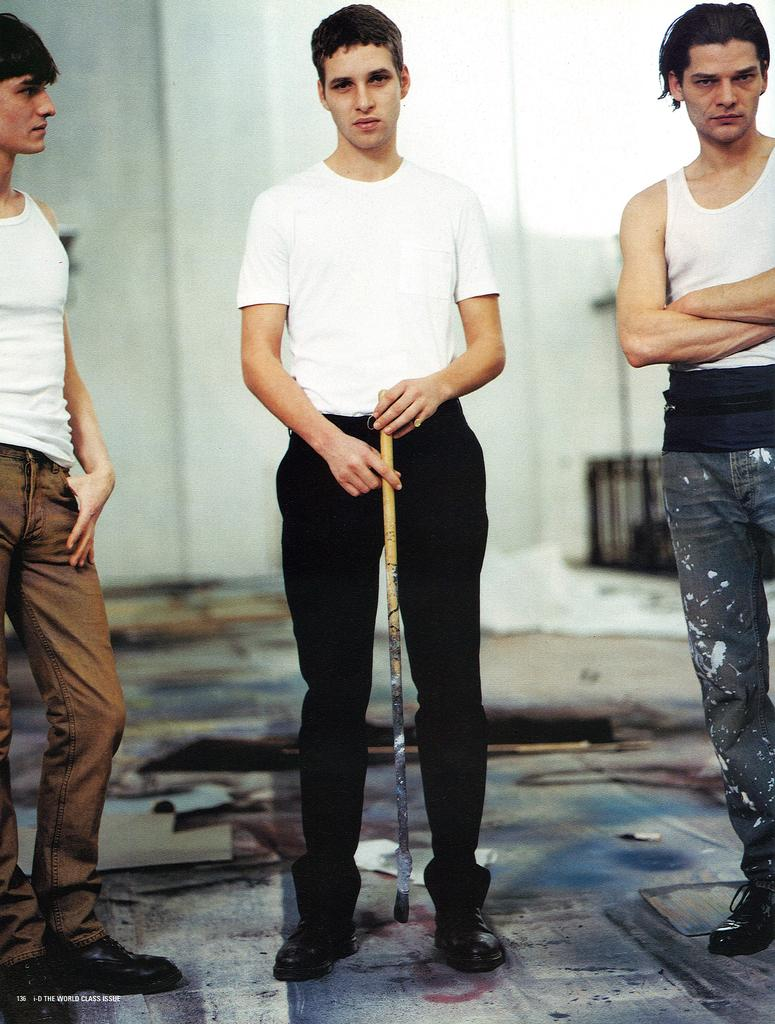How many people are in the image? There are three men in the image. What are the men doing in the image? The men are standing in the image. Can you describe any objects that the men are holding? One man is holding a stick in the image. What can be seen in the background of the image? There is a wall visible in the background of the image. Is there any blood visible on the men in the image? No, there is no blood visible on the men in the image. What types of things are the men discussing in the image? The image does not provide any information about what the men might be discussing. 